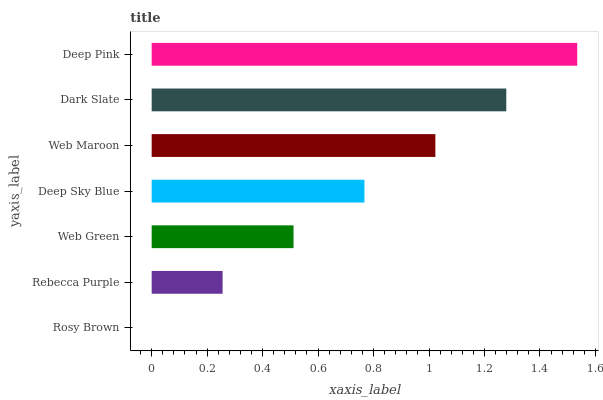Is Rosy Brown the minimum?
Answer yes or no. Yes. Is Deep Pink the maximum?
Answer yes or no. Yes. Is Rebecca Purple the minimum?
Answer yes or no. No. Is Rebecca Purple the maximum?
Answer yes or no. No. Is Rebecca Purple greater than Rosy Brown?
Answer yes or no. Yes. Is Rosy Brown less than Rebecca Purple?
Answer yes or no. Yes. Is Rosy Brown greater than Rebecca Purple?
Answer yes or no. No. Is Rebecca Purple less than Rosy Brown?
Answer yes or no. No. Is Deep Sky Blue the high median?
Answer yes or no. Yes. Is Deep Sky Blue the low median?
Answer yes or no. Yes. Is Deep Pink the high median?
Answer yes or no. No. Is Rebecca Purple the low median?
Answer yes or no. No. 